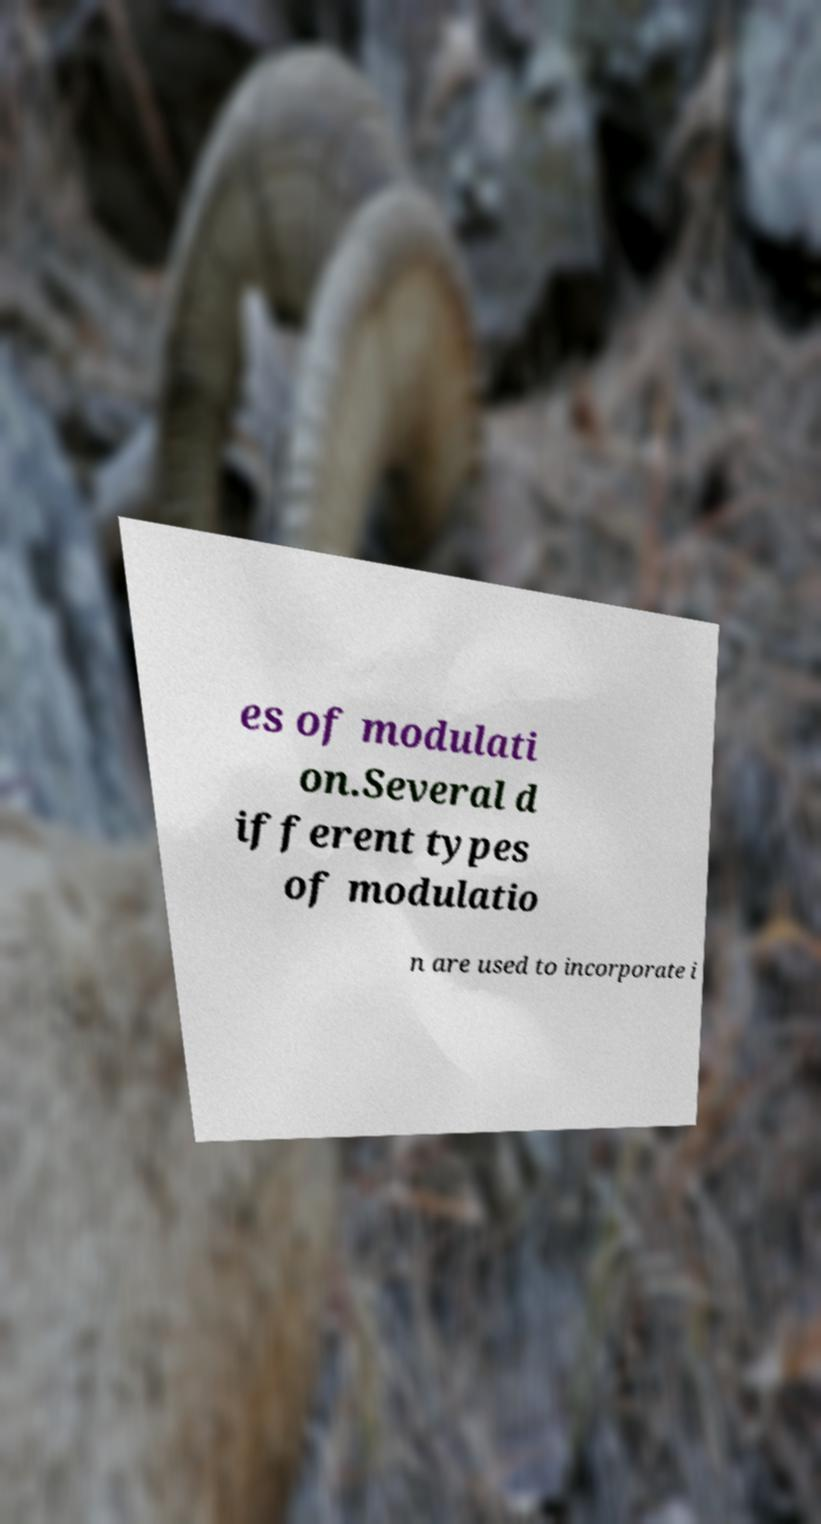Can you read and provide the text displayed in the image?This photo seems to have some interesting text. Can you extract and type it out for me? es of modulati on.Several d ifferent types of modulatio n are used to incorporate i 